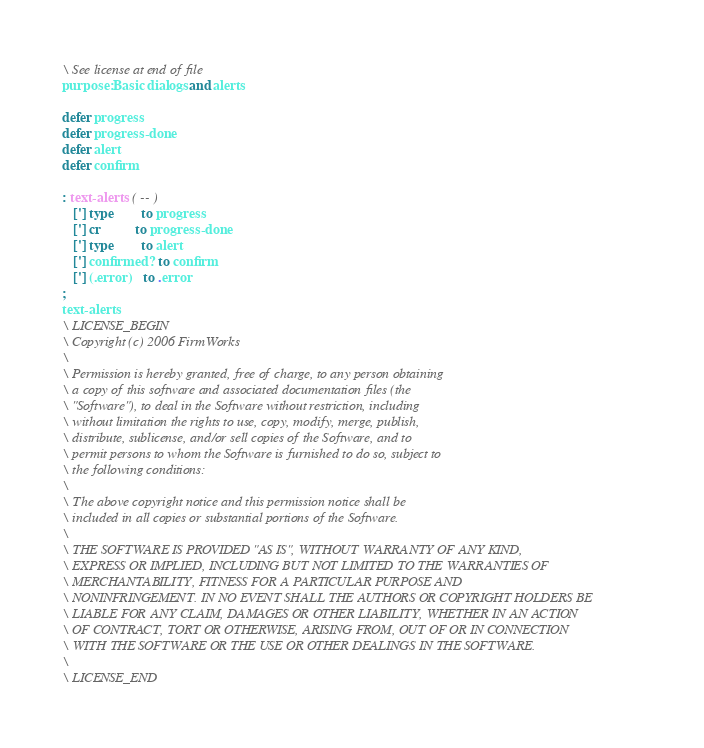Convert code to text. <code><loc_0><loc_0><loc_500><loc_500><_Forth_>\ See license at end of file
purpose: Basic dialogs and alerts

defer progress
defer progress-done
defer alert
defer confirm

: text-alerts  ( -- )
   ['] type        to progress
   ['] cr          to progress-done
   ['] type        to alert
   ['] confirmed?  to confirm
   ['] (.error)    to .error
;
text-alerts
\ LICENSE_BEGIN
\ Copyright (c) 2006 FirmWorks
\ 
\ Permission is hereby granted, free of charge, to any person obtaining
\ a copy of this software and associated documentation files (the
\ "Software"), to deal in the Software without restriction, including
\ without limitation the rights to use, copy, modify, merge, publish,
\ distribute, sublicense, and/or sell copies of the Software, and to
\ permit persons to whom the Software is furnished to do so, subject to
\ the following conditions:
\ 
\ The above copyright notice and this permission notice shall be
\ included in all copies or substantial portions of the Software.
\ 
\ THE SOFTWARE IS PROVIDED "AS IS", WITHOUT WARRANTY OF ANY KIND,
\ EXPRESS OR IMPLIED, INCLUDING BUT NOT LIMITED TO THE WARRANTIES OF
\ MERCHANTABILITY, FITNESS FOR A PARTICULAR PURPOSE AND
\ NONINFRINGEMENT. IN NO EVENT SHALL THE AUTHORS OR COPYRIGHT HOLDERS BE
\ LIABLE FOR ANY CLAIM, DAMAGES OR OTHER LIABILITY, WHETHER IN AN ACTION
\ OF CONTRACT, TORT OR OTHERWISE, ARISING FROM, OUT OF OR IN CONNECTION
\ WITH THE SOFTWARE OR THE USE OR OTHER DEALINGS IN THE SOFTWARE.
\
\ LICENSE_END
</code> 